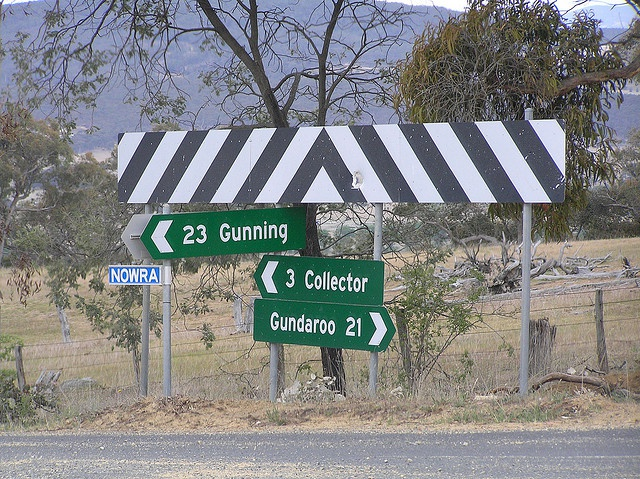Describe the objects in this image and their specific colors. I can see various objects in this image with different colors. 